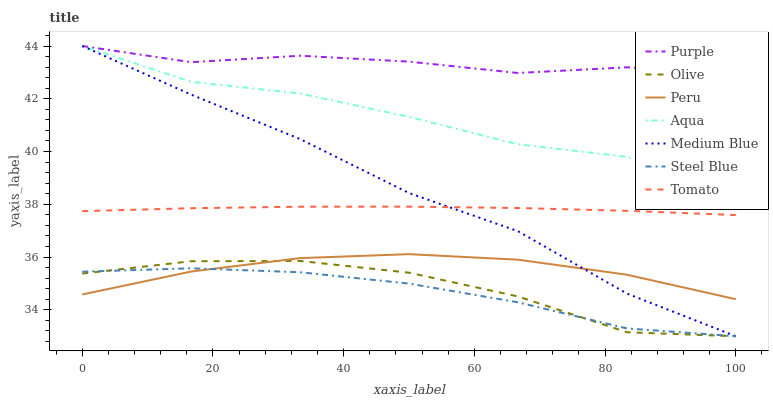Does Steel Blue have the minimum area under the curve?
Answer yes or no. Yes. Does Purple have the maximum area under the curve?
Answer yes or no. Yes. Does Medium Blue have the minimum area under the curve?
Answer yes or no. No. Does Medium Blue have the maximum area under the curve?
Answer yes or no. No. Is Tomato the smoothest?
Answer yes or no. Yes. Is Aqua the roughest?
Answer yes or no. Yes. Is Purple the smoothest?
Answer yes or no. No. Is Purple the roughest?
Answer yes or no. No. Does Purple have the lowest value?
Answer yes or no. No. Does Aqua have the highest value?
Answer yes or no. Yes. Does Steel Blue have the highest value?
Answer yes or no. No. Is Steel Blue less than Aqua?
Answer yes or no. Yes. Is Aqua greater than Olive?
Answer yes or no. Yes. Does Aqua intersect Medium Blue?
Answer yes or no. Yes. Is Aqua less than Medium Blue?
Answer yes or no. No. Is Aqua greater than Medium Blue?
Answer yes or no. No. Does Steel Blue intersect Aqua?
Answer yes or no. No. 